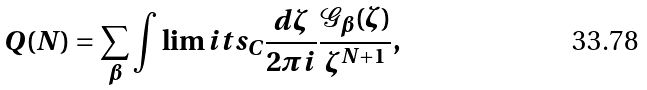<formula> <loc_0><loc_0><loc_500><loc_500>Q ( N ) = \sum _ { \beta } \int \lim i t s _ { C } \frac { d \zeta } { 2 \pi i } \frac { \mathcal { G } _ { \beta } ( \zeta ) } { \zeta ^ { N + 1 } } ,</formula> 